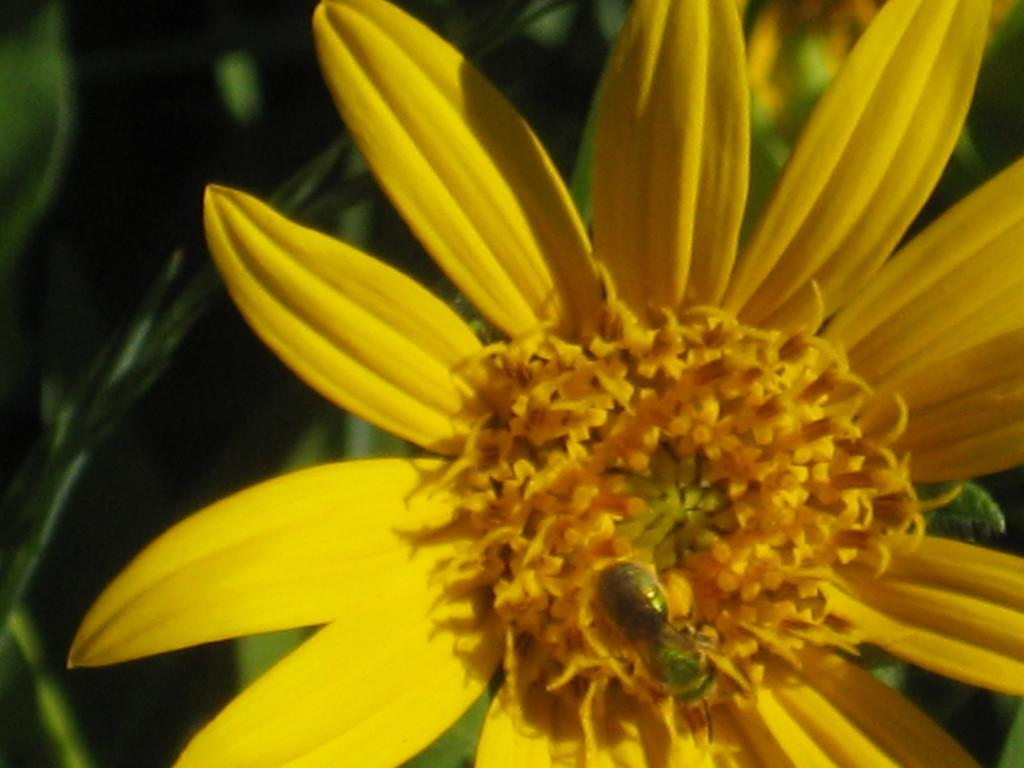What is the main subject of the image? There is a flower in the image. Is there anything else on the flower? Yes, an insect is present on the flower. What can be seen behind the flower? There are leaves behind the flower. What type of rhythm can be heard coming from the flower in the image? There is no sound or rhythm associated with the flower in the image. 